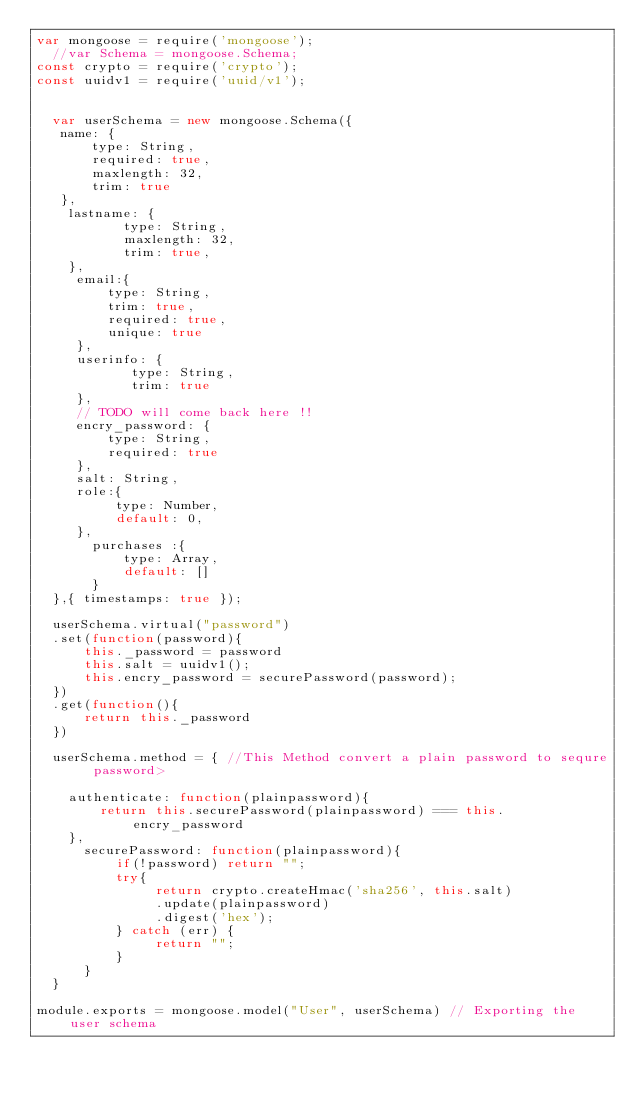Convert code to text. <code><loc_0><loc_0><loc_500><loc_500><_JavaScript_>var mongoose = require('mongoose');
  //var Schema = mongoose.Schema;
const crypto = require('crypto');
const uuidv1 = require('uuid/v1');


  var userSchema = new mongoose.Schema({
   name: {
       type: String,
       required: true,
       maxlength: 32,
       trim: true
   },
    lastname: {
           type: String,
           maxlength: 32,
           trim: true,
    },
     email:{
         type: String,
         trim: true,
         required: true,
         unique: true
     },
     userinfo: {
            type: String,
            trim: true
     },
     // TODO will come back here !!
     encry_password: {
         type: String,
         required: true
     },
     salt: String,
     role:{
          type: Number,
          default: 0,
     },
       purchases :{
           type: Array,
           default: []
       }
  },{ timestamps: true });

  userSchema.virtual("password")
  .set(function(password){
      this._password = password
      this.salt = uuidv1();
      this.encry_password = securePassword(password);
  })
  .get(function(){
      return this._password
  })

  userSchema.method = { //This Method convert a plain password to sequre password>

    authenticate: function(plainpassword){
        return this.securePassword(plainpassword) === this.encry_password
    },
      securePassword: function(plainpassword){
          if(!password) return "";
          try{
               return crypto.createHmac('sha256', this.salt)
               .update(plainpassword)
               .digest('hex');
          } catch (err) {
               return "";
          }
      }
  }

module.exports = mongoose.model("User", userSchema) // Exporting the user schema 
</code> 